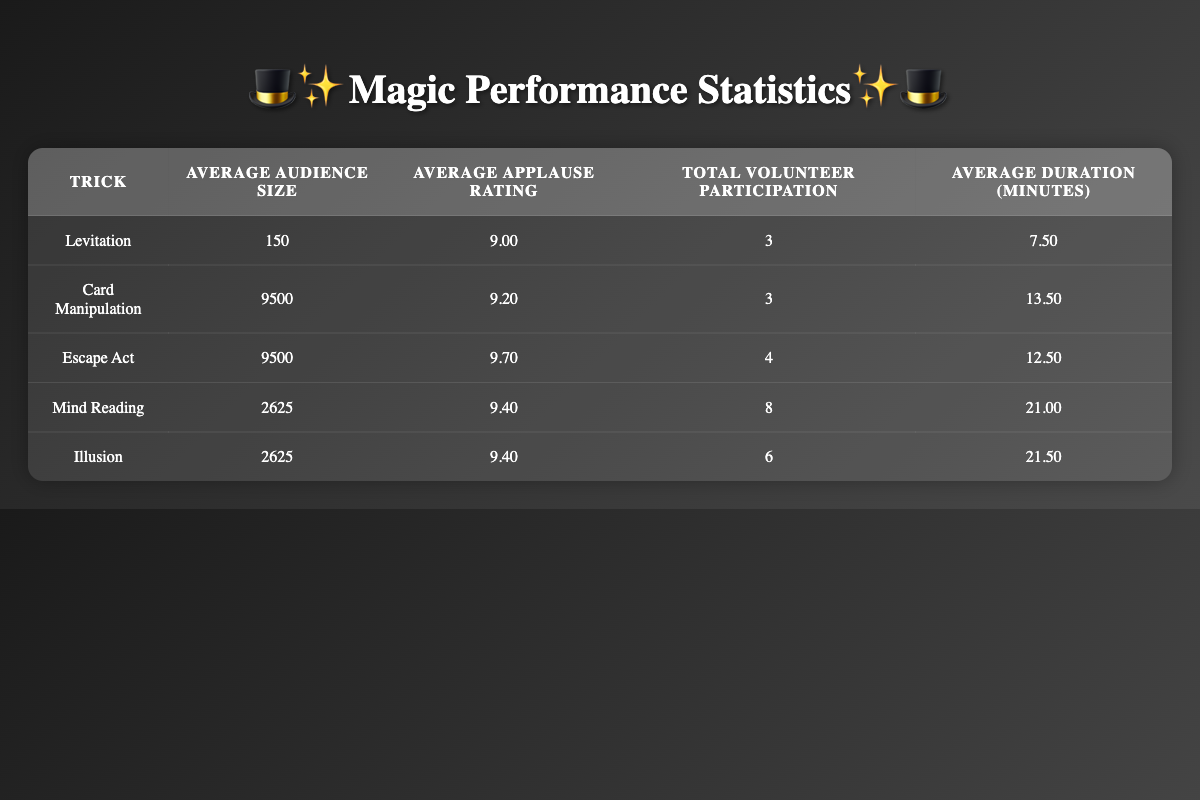What is the average audience size for the Illusion trick? The audience size for the Illusion trick is 2625, as indicated in the table.
Answer: 2625 Which magician had the highest applause rating? By comparing the applause ratings in the table, David Copperfield's Illusion trick has the highest rating of 9.9.
Answer: David Copperfield What is the total volunteer participation across all tricks? To find the total volunteer participation, we sum the values: 3 + 3 + 4 + 8 + 6 = 24.
Answer: 24 What is the average duration of the Mind Reading trick? The average duration for the Mind Reading trick is 21.00 minutes, which is specifically mentioned in the table.
Answer: 21.00 minutes Is the average applause rating for Escape Act greater than 9? The average applause rating for Escape Act is 9.70, which is indeed greater than 9.
Answer: Yes Which trick had the largest audience size? The Escape Act trick had the largest audience size of 17000, as stated in the table.
Answer: Escape Act How many tricks have an average applause rating above 9.5? The tricks that have an average applause rating above 9.5 are Escape Act (9.70), Mind Reading (9.40), and Illusion (9.40). Therefore, there are 2 tricks above 9.5 when considering only Escape Act.
Answer: 1 trick What is the difference between the average audience size for Card Manipulation and Levitation? To find the difference, we calculate: 9500 (Card Manipulation) - 150 (Levitation) = 9350. Therefore, the difference is 9350.
Answer: 9350 Which trick had the highest volunteer participation? The Mind Reading trick had the highest volunteer participation with a total of 8 participants.
Answer: Mind Reading 